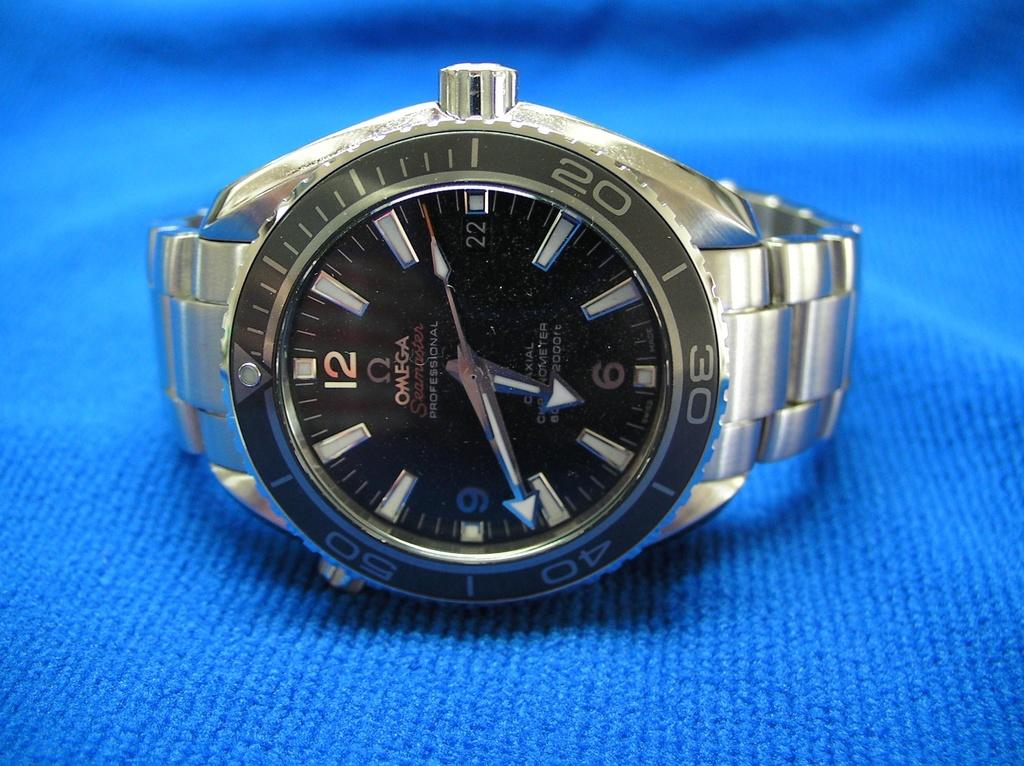<image>
Present a compact description of the photo's key features. A close up of an OMEGA watch with the time of 6:41 